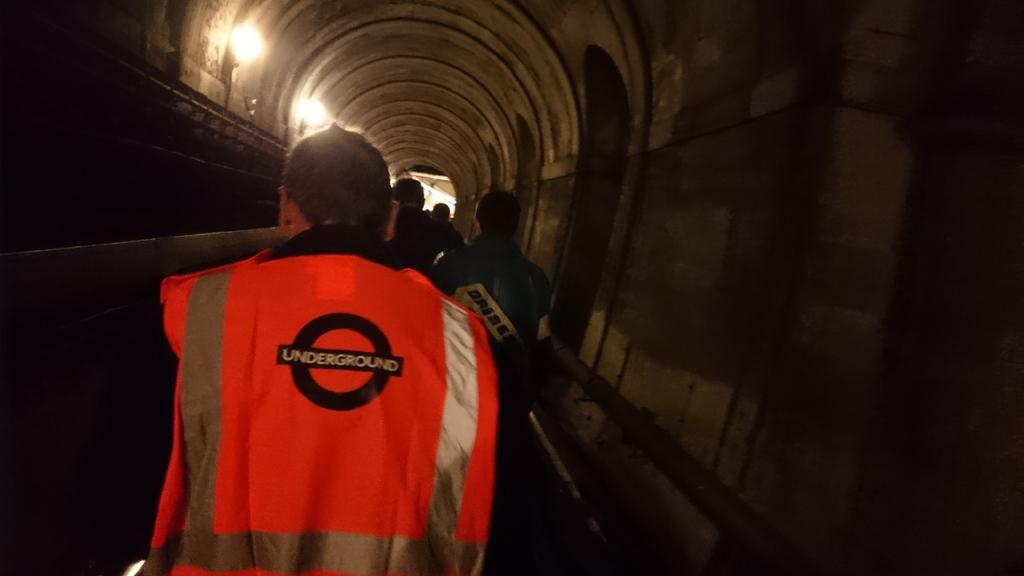Provide a one-sentence caption for the provided image. A man wearing an Underground vest walks with others in a tunnel. 